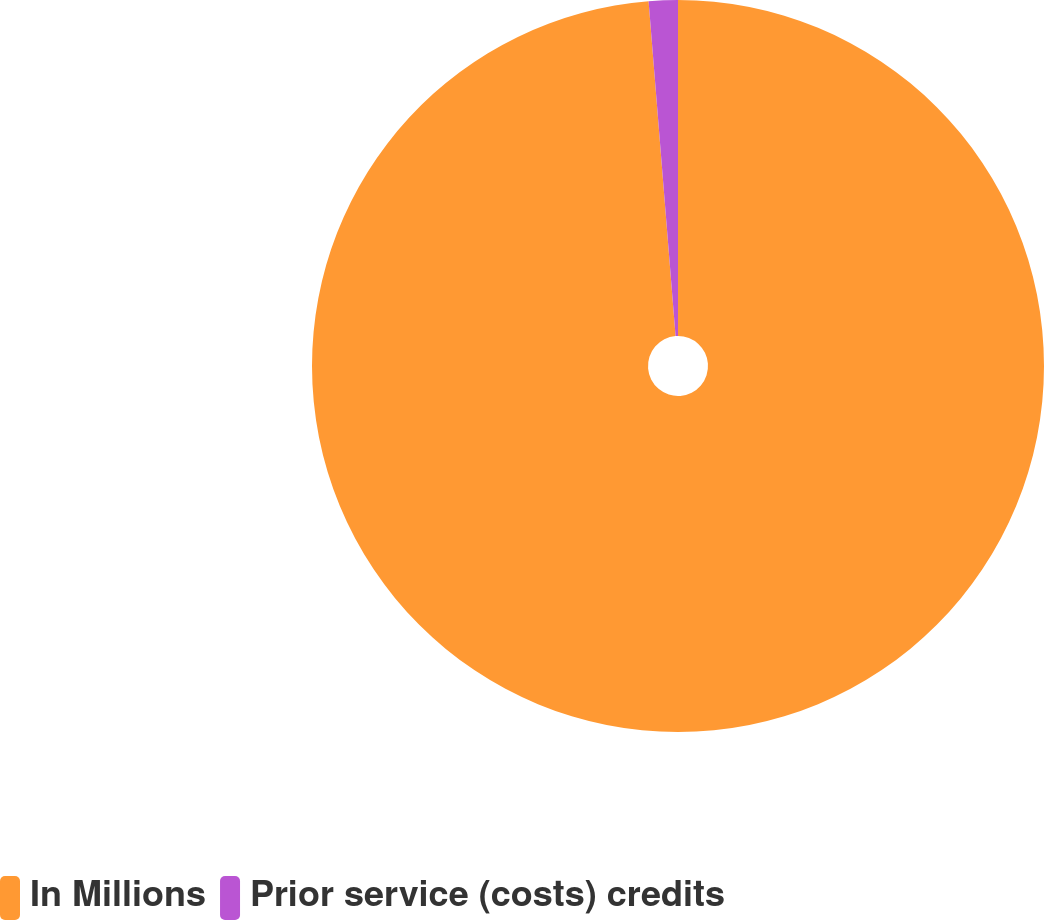Convert chart to OTSL. <chart><loc_0><loc_0><loc_500><loc_500><pie_chart><fcel>In Millions<fcel>Prior service (costs) credits<nl><fcel>98.72%<fcel>1.28%<nl></chart> 